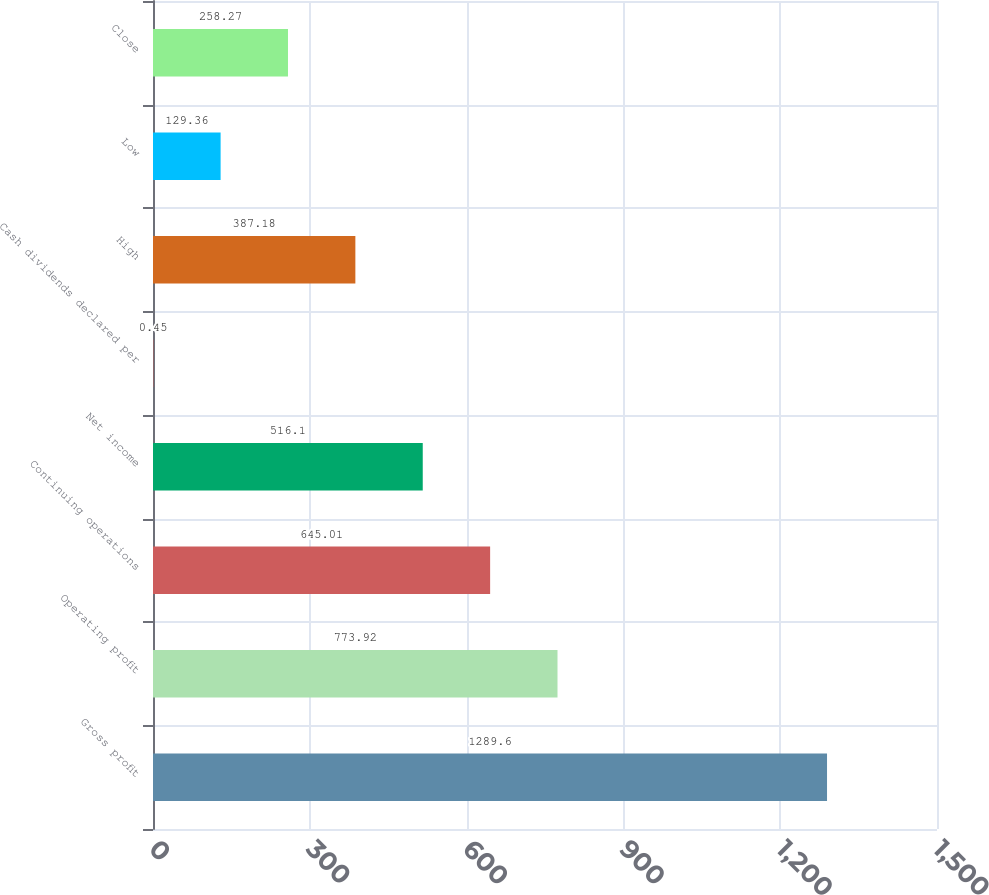<chart> <loc_0><loc_0><loc_500><loc_500><bar_chart><fcel>Gross profit<fcel>Operating profit<fcel>Continuing operations<fcel>Net income<fcel>Cash dividends declared per<fcel>High<fcel>Low<fcel>Close<nl><fcel>1289.6<fcel>773.92<fcel>645.01<fcel>516.1<fcel>0.45<fcel>387.18<fcel>129.36<fcel>258.27<nl></chart> 